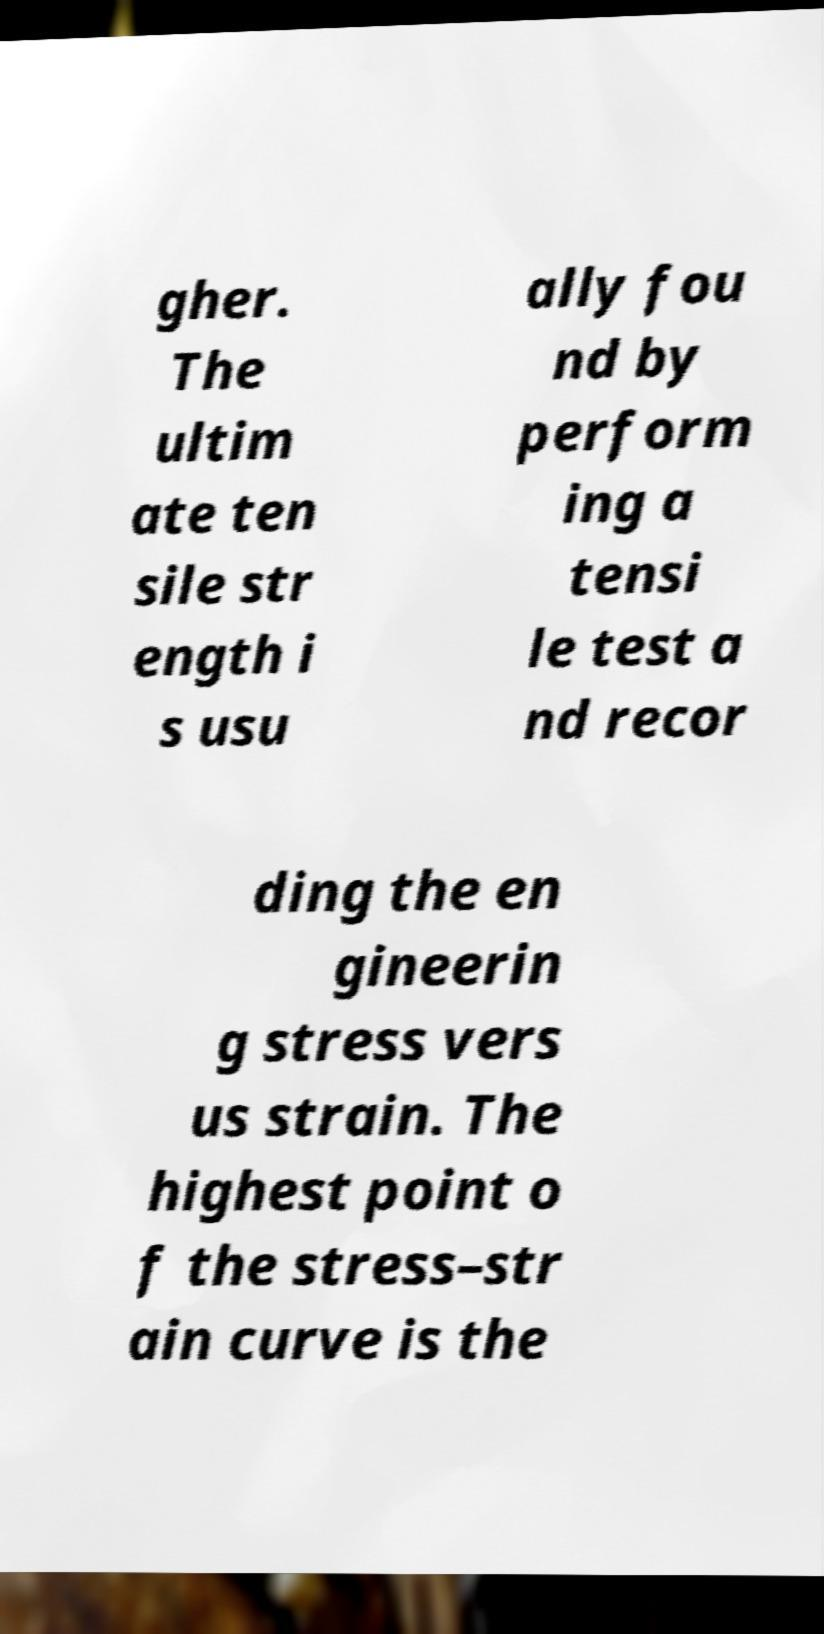Can you read and provide the text displayed in the image?This photo seems to have some interesting text. Can you extract and type it out for me? gher. The ultim ate ten sile str ength i s usu ally fou nd by perform ing a tensi le test a nd recor ding the en gineerin g stress vers us strain. The highest point o f the stress–str ain curve is the 